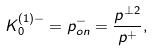Convert formula to latex. <formula><loc_0><loc_0><loc_500><loc_500>K _ { 0 } ^ { ( 1 ) - } = p _ { o n } ^ { - } = \frac { p ^ { \perp 2 } } { p ^ { + } } ,</formula> 